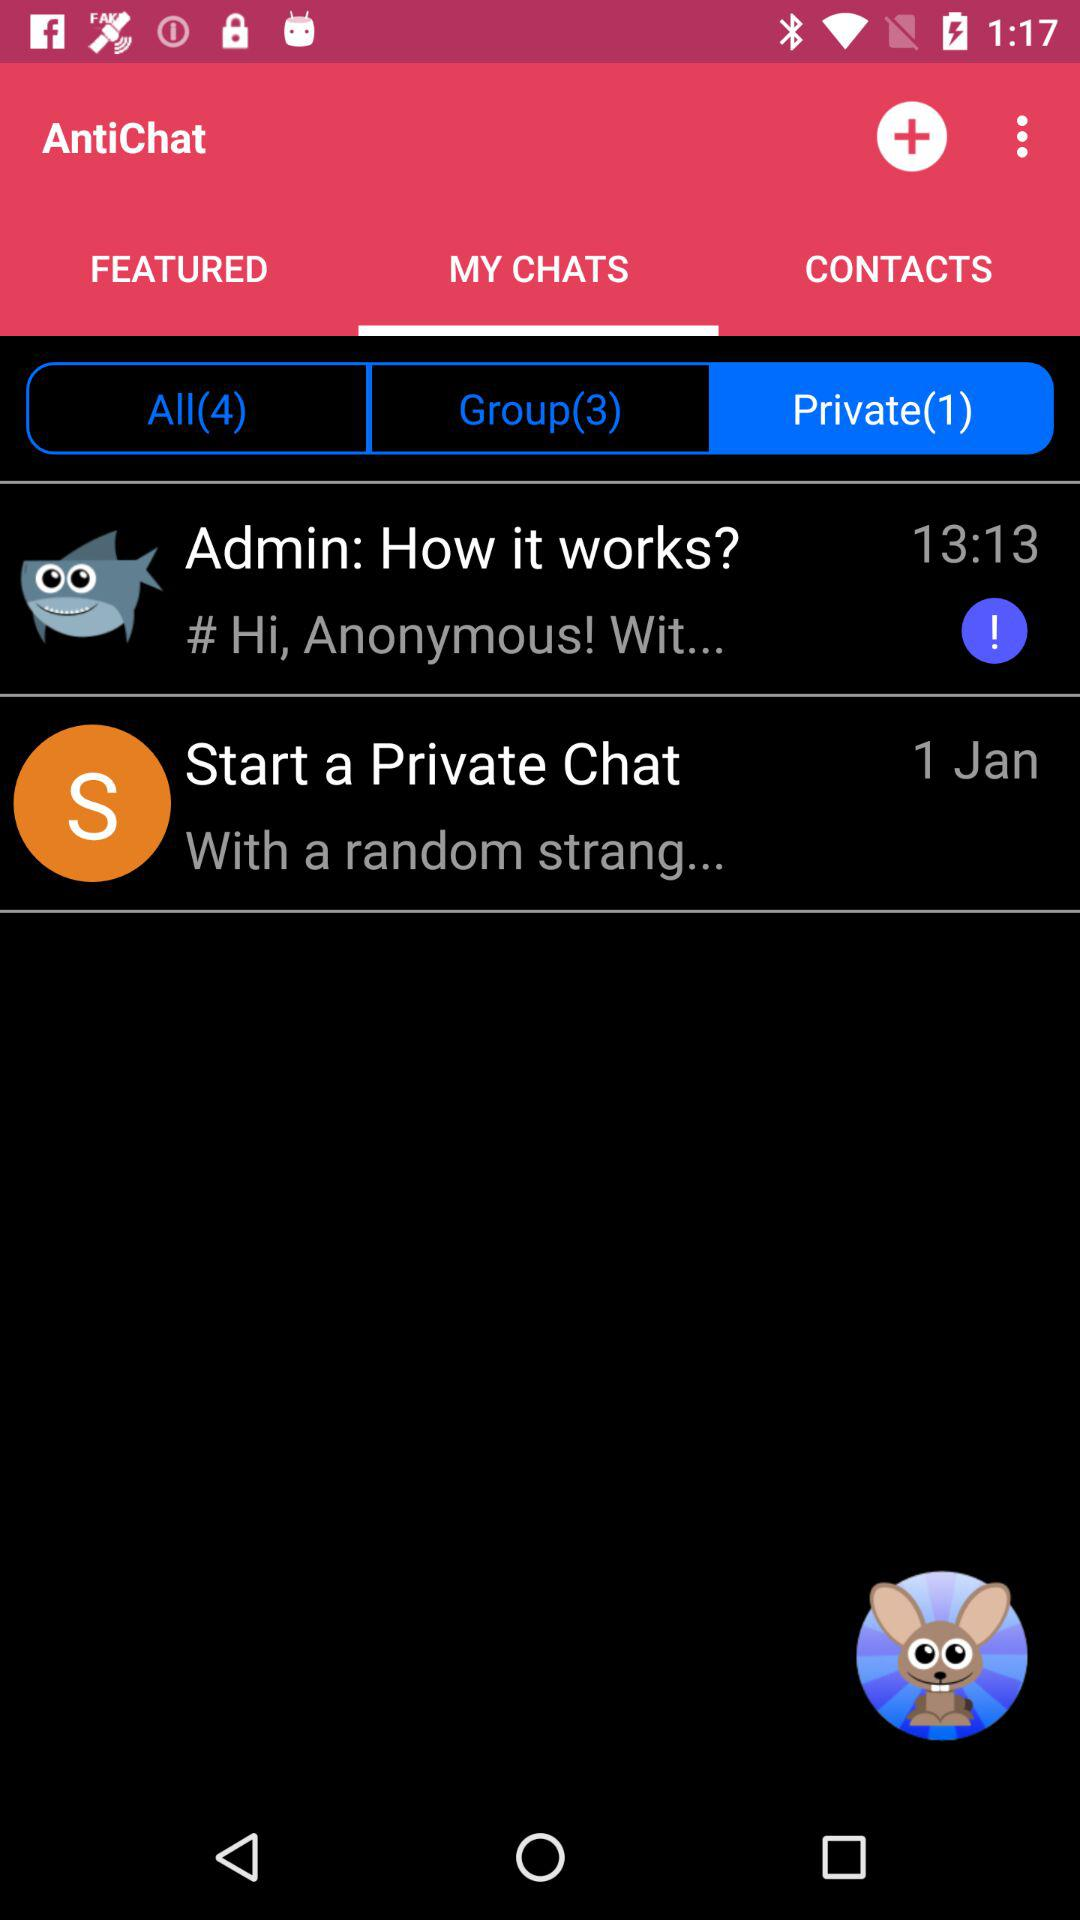What was the time of the last private chat? The time for the last private chat was 13:13. 